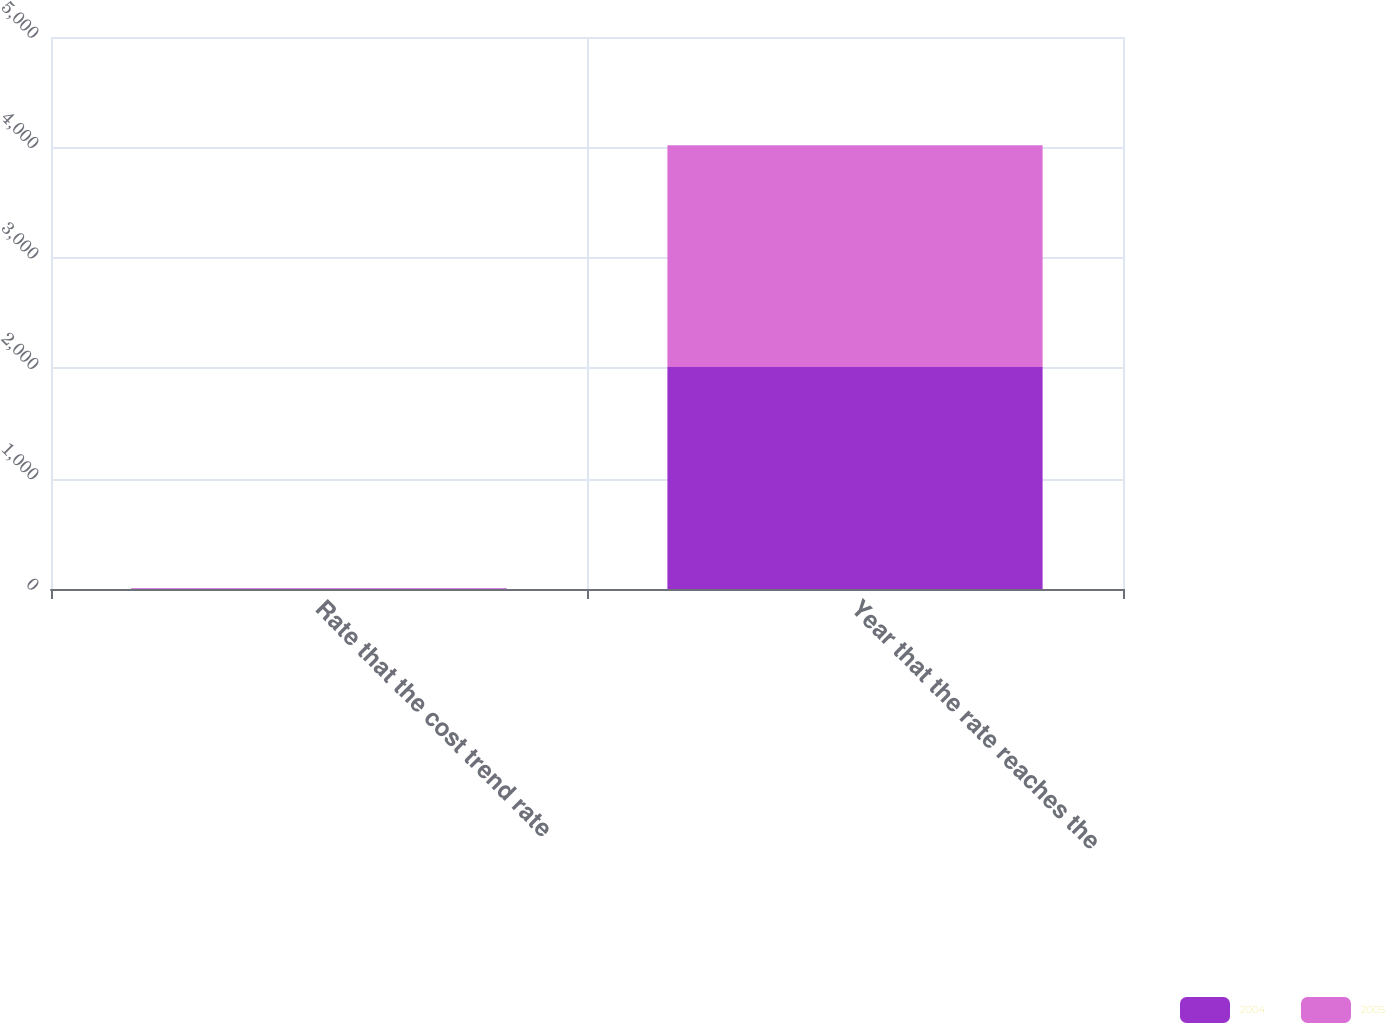Convert chart to OTSL. <chart><loc_0><loc_0><loc_500><loc_500><stacked_bar_chart><ecel><fcel>Rate that the cost trend rate<fcel>Year that the rate reaches the<nl><fcel>2004<fcel>5<fcel>2010<nl><fcel>2005<fcel>5<fcel>2010<nl></chart> 